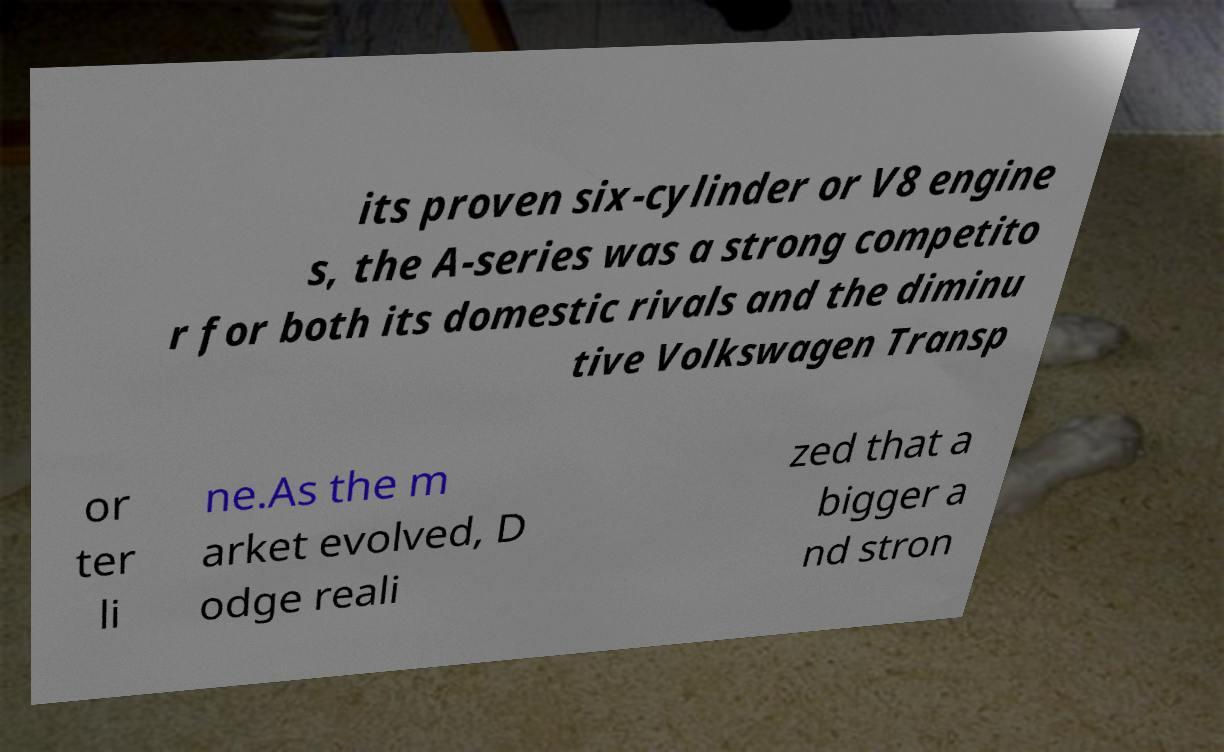What messages or text are displayed in this image? I need them in a readable, typed format. its proven six-cylinder or V8 engine s, the A-series was a strong competito r for both its domestic rivals and the diminu tive Volkswagen Transp or ter li ne.As the m arket evolved, D odge reali zed that a bigger a nd stron 